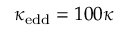<formula> <loc_0><loc_0><loc_500><loc_500>\kappa _ { e d d } = 1 0 0 \kappa</formula> 